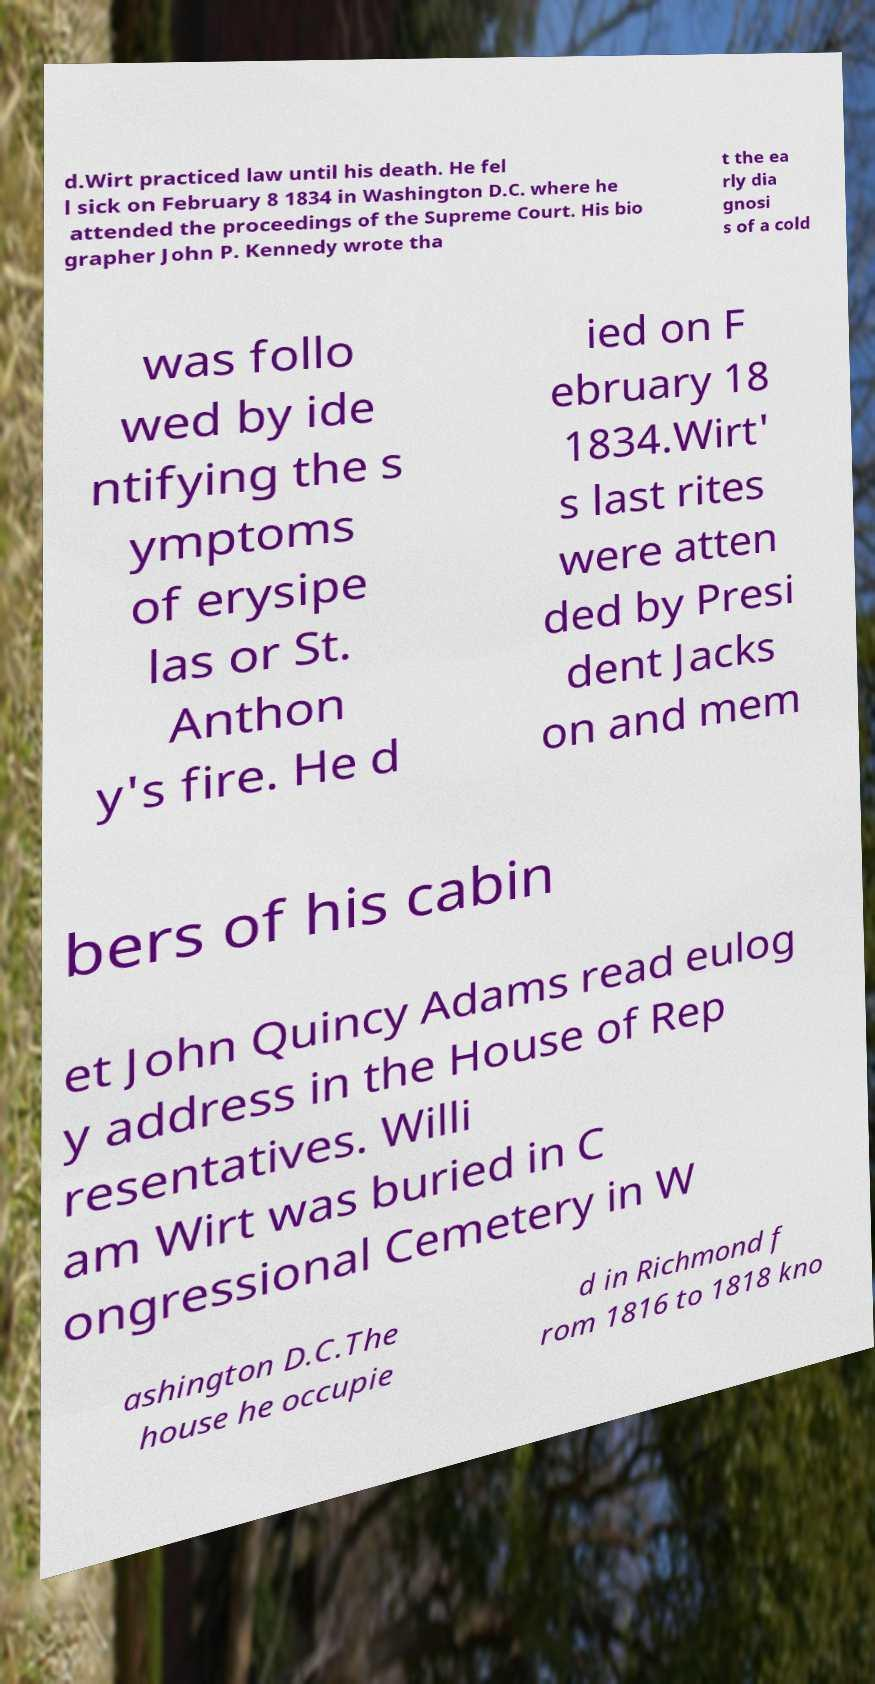I need the written content from this picture converted into text. Can you do that? d.Wirt practiced law until his death. He fel l sick on February 8 1834 in Washington D.C. where he attended the proceedings of the Supreme Court. His bio grapher John P. Kennedy wrote tha t the ea rly dia gnosi s of a cold was follo wed by ide ntifying the s ymptoms of erysipe las or St. Anthon y's fire. He d ied on F ebruary 18 1834.Wirt' s last rites were atten ded by Presi dent Jacks on and mem bers of his cabin et John Quincy Adams read eulog y address in the House of Rep resentatives. Willi am Wirt was buried in C ongressional Cemetery in W ashington D.C.The house he occupie d in Richmond f rom 1816 to 1818 kno 